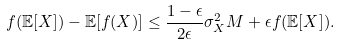<formula> <loc_0><loc_0><loc_500><loc_500>f ( \mathbb { E } [ X ] ) - \mathbb { E } [ f ( X ) ] \leq \frac { 1 - \epsilon } { 2 \epsilon } \sigma _ { X } ^ { 2 } M + \epsilon f ( \mathbb { E } [ X ] ) .</formula> 